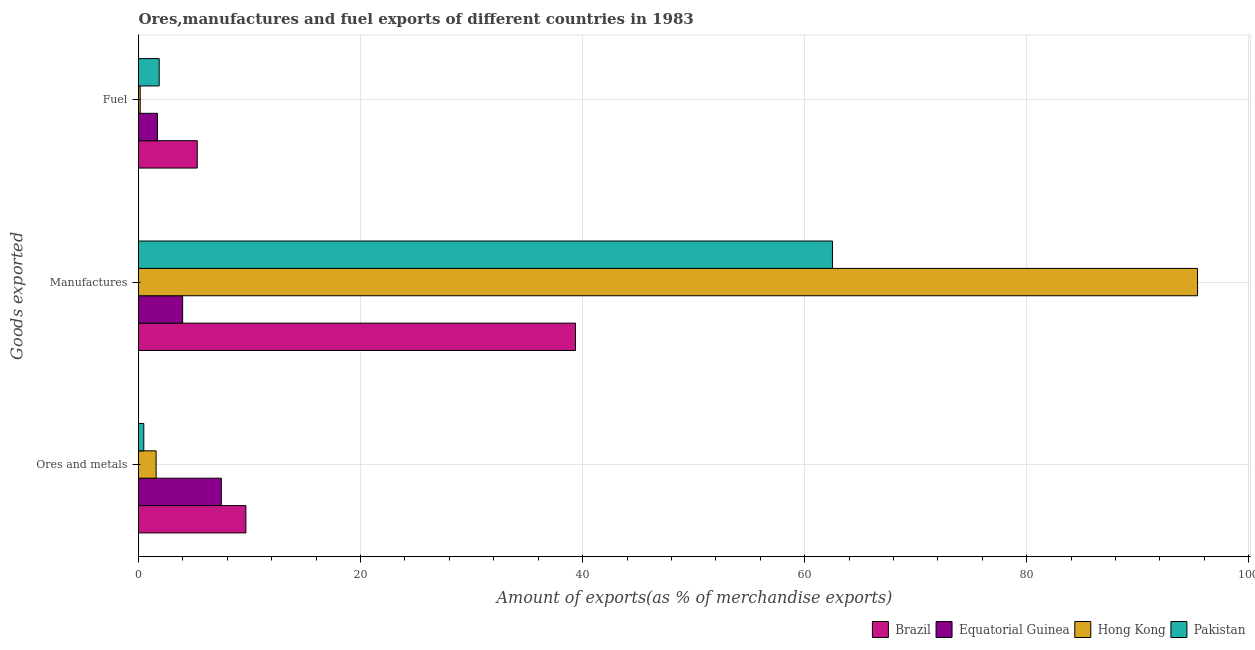Are the number of bars on each tick of the Y-axis equal?
Your answer should be compact. Yes. How many bars are there on the 3rd tick from the top?
Offer a very short reply. 4. What is the label of the 3rd group of bars from the top?
Make the answer very short. Ores and metals. What is the percentage of fuel exports in Hong Kong?
Offer a terse response. 0.15. Across all countries, what is the maximum percentage of ores and metals exports?
Keep it short and to the point. 9.67. Across all countries, what is the minimum percentage of ores and metals exports?
Keep it short and to the point. 0.48. In which country was the percentage of fuel exports maximum?
Offer a very short reply. Brazil. In which country was the percentage of manufactures exports minimum?
Your answer should be very brief. Equatorial Guinea. What is the total percentage of ores and metals exports in the graph?
Your answer should be very brief. 19.19. What is the difference between the percentage of manufactures exports in Brazil and that in Pakistan?
Offer a terse response. -23.15. What is the difference between the percentage of ores and metals exports in Pakistan and the percentage of fuel exports in Brazil?
Your answer should be very brief. -4.82. What is the average percentage of fuel exports per country?
Make the answer very short. 2.25. What is the difference between the percentage of fuel exports and percentage of ores and metals exports in Brazil?
Make the answer very short. -4.38. In how many countries, is the percentage of ores and metals exports greater than 36 %?
Provide a succinct answer. 0. What is the ratio of the percentage of ores and metals exports in Hong Kong to that in Pakistan?
Give a very brief answer. 3.33. Is the percentage of manufactures exports in Brazil less than that in Equatorial Guinea?
Offer a terse response. No. Is the difference between the percentage of ores and metals exports in Hong Kong and Pakistan greater than the difference between the percentage of fuel exports in Hong Kong and Pakistan?
Your response must be concise. Yes. What is the difference between the highest and the second highest percentage of manufactures exports?
Make the answer very short. 32.88. What is the difference between the highest and the lowest percentage of ores and metals exports?
Your answer should be very brief. 9.2. Is the sum of the percentage of ores and metals exports in Brazil and Equatorial Guinea greater than the maximum percentage of manufactures exports across all countries?
Provide a short and direct response. No. What does the 1st bar from the bottom in Ores and metals represents?
Offer a very short reply. Brazil. Are all the bars in the graph horizontal?
Give a very brief answer. Yes. What is the difference between two consecutive major ticks on the X-axis?
Your answer should be compact. 20. Are the values on the major ticks of X-axis written in scientific E-notation?
Keep it short and to the point. No. Does the graph contain any zero values?
Your answer should be very brief. No. Does the graph contain grids?
Offer a very short reply. Yes. Where does the legend appear in the graph?
Your answer should be compact. Bottom right. What is the title of the graph?
Provide a short and direct response. Ores,manufactures and fuel exports of different countries in 1983. What is the label or title of the X-axis?
Make the answer very short. Amount of exports(as % of merchandise exports). What is the label or title of the Y-axis?
Make the answer very short. Goods exported. What is the Amount of exports(as % of merchandise exports) of Brazil in Ores and metals?
Your answer should be very brief. 9.67. What is the Amount of exports(as % of merchandise exports) in Equatorial Guinea in Ores and metals?
Provide a short and direct response. 7.46. What is the Amount of exports(as % of merchandise exports) of Hong Kong in Ores and metals?
Give a very brief answer. 1.59. What is the Amount of exports(as % of merchandise exports) in Pakistan in Ores and metals?
Provide a succinct answer. 0.48. What is the Amount of exports(as % of merchandise exports) of Brazil in Manufactures?
Your response must be concise. 39.36. What is the Amount of exports(as % of merchandise exports) of Equatorial Guinea in Manufactures?
Your answer should be compact. 3.97. What is the Amount of exports(as % of merchandise exports) in Hong Kong in Manufactures?
Give a very brief answer. 95.39. What is the Amount of exports(as % of merchandise exports) in Pakistan in Manufactures?
Give a very brief answer. 62.51. What is the Amount of exports(as % of merchandise exports) in Brazil in Fuel?
Keep it short and to the point. 5.29. What is the Amount of exports(as % of merchandise exports) in Equatorial Guinea in Fuel?
Offer a very short reply. 1.71. What is the Amount of exports(as % of merchandise exports) in Hong Kong in Fuel?
Offer a terse response. 0.15. What is the Amount of exports(as % of merchandise exports) in Pakistan in Fuel?
Offer a terse response. 1.86. Across all Goods exported, what is the maximum Amount of exports(as % of merchandise exports) of Brazil?
Offer a terse response. 39.36. Across all Goods exported, what is the maximum Amount of exports(as % of merchandise exports) of Equatorial Guinea?
Your response must be concise. 7.46. Across all Goods exported, what is the maximum Amount of exports(as % of merchandise exports) of Hong Kong?
Offer a terse response. 95.39. Across all Goods exported, what is the maximum Amount of exports(as % of merchandise exports) of Pakistan?
Ensure brevity in your answer.  62.51. Across all Goods exported, what is the minimum Amount of exports(as % of merchandise exports) in Brazil?
Provide a short and direct response. 5.29. Across all Goods exported, what is the minimum Amount of exports(as % of merchandise exports) of Equatorial Guinea?
Give a very brief answer. 1.71. Across all Goods exported, what is the minimum Amount of exports(as % of merchandise exports) in Hong Kong?
Provide a succinct answer. 0.15. Across all Goods exported, what is the minimum Amount of exports(as % of merchandise exports) in Pakistan?
Your answer should be compact. 0.48. What is the total Amount of exports(as % of merchandise exports) of Brazil in the graph?
Offer a terse response. 54.32. What is the total Amount of exports(as % of merchandise exports) in Equatorial Guinea in the graph?
Your answer should be compact. 13.14. What is the total Amount of exports(as % of merchandise exports) of Hong Kong in the graph?
Offer a very short reply. 97.13. What is the total Amount of exports(as % of merchandise exports) in Pakistan in the graph?
Your response must be concise. 64.84. What is the difference between the Amount of exports(as % of merchandise exports) of Brazil in Ores and metals and that in Manufactures?
Give a very brief answer. -29.69. What is the difference between the Amount of exports(as % of merchandise exports) in Equatorial Guinea in Ores and metals and that in Manufactures?
Provide a short and direct response. 3.49. What is the difference between the Amount of exports(as % of merchandise exports) of Hong Kong in Ores and metals and that in Manufactures?
Keep it short and to the point. -93.8. What is the difference between the Amount of exports(as % of merchandise exports) in Pakistan in Ores and metals and that in Manufactures?
Make the answer very short. -62.03. What is the difference between the Amount of exports(as % of merchandise exports) in Brazil in Ores and metals and that in Fuel?
Your response must be concise. 4.38. What is the difference between the Amount of exports(as % of merchandise exports) of Equatorial Guinea in Ores and metals and that in Fuel?
Your response must be concise. 5.75. What is the difference between the Amount of exports(as % of merchandise exports) of Hong Kong in Ores and metals and that in Fuel?
Provide a succinct answer. 1.43. What is the difference between the Amount of exports(as % of merchandise exports) in Pakistan in Ores and metals and that in Fuel?
Ensure brevity in your answer.  -1.39. What is the difference between the Amount of exports(as % of merchandise exports) of Brazil in Manufactures and that in Fuel?
Provide a short and direct response. 34.07. What is the difference between the Amount of exports(as % of merchandise exports) of Equatorial Guinea in Manufactures and that in Fuel?
Give a very brief answer. 2.27. What is the difference between the Amount of exports(as % of merchandise exports) of Hong Kong in Manufactures and that in Fuel?
Keep it short and to the point. 95.24. What is the difference between the Amount of exports(as % of merchandise exports) in Pakistan in Manufactures and that in Fuel?
Make the answer very short. 60.64. What is the difference between the Amount of exports(as % of merchandise exports) in Brazil in Ores and metals and the Amount of exports(as % of merchandise exports) in Equatorial Guinea in Manufactures?
Your answer should be very brief. 5.7. What is the difference between the Amount of exports(as % of merchandise exports) of Brazil in Ores and metals and the Amount of exports(as % of merchandise exports) of Hong Kong in Manufactures?
Provide a short and direct response. -85.72. What is the difference between the Amount of exports(as % of merchandise exports) of Brazil in Ores and metals and the Amount of exports(as % of merchandise exports) of Pakistan in Manufactures?
Offer a very short reply. -52.83. What is the difference between the Amount of exports(as % of merchandise exports) in Equatorial Guinea in Ores and metals and the Amount of exports(as % of merchandise exports) in Hong Kong in Manufactures?
Offer a terse response. -87.93. What is the difference between the Amount of exports(as % of merchandise exports) in Equatorial Guinea in Ores and metals and the Amount of exports(as % of merchandise exports) in Pakistan in Manufactures?
Your response must be concise. -55.05. What is the difference between the Amount of exports(as % of merchandise exports) in Hong Kong in Ores and metals and the Amount of exports(as % of merchandise exports) in Pakistan in Manufactures?
Keep it short and to the point. -60.92. What is the difference between the Amount of exports(as % of merchandise exports) in Brazil in Ores and metals and the Amount of exports(as % of merchandise exports) in Equatorial Guinea in Fuel?
Provide a succinct answer. 7.96. What is the difference between the Amount of exports(as % of merchandise exports) of Brazil in Ores and metals and the Amount of exports(as % of merchandise exports) of Hong Kong in Fuel?
Ensure brevity in your answer.  9.52. What is the difference between the Amount of exports(as % of merchandise exports) of Brazil in Ores and metals and the Amount of exports(as % of merchandise exports) of Pakistan in Fuel?
Your answer should be compact. 7.81. What is the difference between the Amount of exports(as % of merchandise exports) in Equatorial Guinea in Ores and metals and the Amount of exports(as % of merchandise exports) in Hong Kong in Fuel?
Provide a short and direct response. 7.31. What is the difference between the Amount of exports(as % of merchandise exports) of Equatorial Guinea in Ores and metals and the Amount of exports(as % of merchandise exports) of Pakistan in Fuel?
Provide a short and direct response. 5.6. What is the difference between the Amount of exports(as % of merchandise exports) in Hong Kong in Ores and metals and the Amount of exports(as % of merchandise exports) in Pakistan in Fuel?
Offer a very short reply. -0.28. What is the difference between the Amount of exports(as % of merchandise exports) in Brazil in Manufactures and the Amount of exports(as % of merchandise exports) in Equatorial Guinea in Fuel?
Make the answer very short. 37.65. What is the difference between the Amount of exports(as % of merchandise exports) in Brazil in Manufactures and the Amount of exports(as % of merchandise exports) in Hong Kong in Fuel?
Provide a succinct answer. 39.21. What is the difference between the Amount of exports(as % of merchandise exports) in Brazil in Manufactures and the Amount of exports(as % of merchandise exports) in Pakistan in Fuel?
Keep it short and to the point. 37.5. What is the difference between the Amount of exports(as % of merchandise exports) in Equatorial Guinea in Manufactures and the Amount of exports(as % of merchandise exports) in Hong Kong in Fuel?
Your answer should be very brief. 3.82. What is the difference between the Amount of exports(as % of merchandise exports) of Equatorial Guinea in Manufactures and the Amount of exports(as % of merchandise exports) of Pakistan in Fuel?
Your response must be concise. 2.11. What is the difference between the Amount of exports(as % of merchandise exports) of Hong Kong in Manufactures and the Amount of exports(as % of merchandise exports) of Pakistan in Fuel?
Your answer should be compact. 93.53. What is the average Amount of exports(as % of merchandise exports) of Brazil per Goods exported?
Ensure brevity in your answer.  18.11. What is the average Amount of exports(as % of merchandise exports) of Equatorial Guinea per Goods exported?
Offer a terse response. 4.38. What is the average Amount of exports(as % of merchandise exports) in Hong Kong per Goods exported?
Give a very brief answer. 32.38. What is the average Amount of exports(as % of merchandise exports) of Pakistan per Goods exported?
Your answer should be very brief. 21.61. What is the difference between the Amount of exports(as % of merchandise exports) of Brazil and Amount of exports(as % of merchandise exports) of Equatorial Guinea in Ores and metals?
Offer a terse response. 2.21. What is the difference between the Amount of exports(as % of merchandise exports) of Brazil and Amount of exports(as % of merchandise exports) of Hong Kong in Ores and metals?
Offer a terse response. 8.09. What is the difference between the Amount of exports(as % of merchandise exports) of Brazil and Amount of exports(as % of merchandise exports) of Pakistan in Ores and metals?
Your answer should be compact. 9.2. What is the difference between the Amount of exports(as % of merchandise exports) in Equatorial Guinea and Amount of exports(as % of merchandise exports) in Hong Kong in Ores and metals?
Offer a terse response. 5.87. What is the difference between the Amount of exports(as % of merchandise exports) of Equatorial Guinea and Amount of exports(as % of merchandise exports) of Pakistan in Ores and metals?
Keep it short and to the point. 6.98. What is the difference between the Amount of exports(as % of merchandise exports) of Hong Kong and Amount of exports(as % of merchandise exports) of Pakistan in Ores and metals?
Offer a very short reply. 1.11. What is the difference between the Amount of exports(as % of merchandise exports) in Brazil and Amount of exports(as % of merchandise exports) in Equatorial Guinea in Manufactures?
Ensure brevity in your answer.  35.39. What is the difference between the Amount of exports(as % of merchandise exports) in Brazil and Amount of exports(as % of merchandise exports) in Hong Kong in Manufactures?
Keep it short and to the point. -56.03. What is the difference between the Amount of exports(as % of merchandise exports) of Brazil and Amount of exports(as % of merchandise exports) of Pakistan in Manufactures?
Your answer should be compact. -23.15. What is the difference between the Amount of exports(as % of merchandise exports) of Equatorial Guinea and Amount of exports(as % of merchandise exports) of Hong Kong in Manufactures?
Provide a succinct answer. -91.42. What is the difference between the Amount of exports(as % of merchandise exports) in Equatorial Guinea and Amount of exports(as % of merchandise exports) in Pakistan in Manufactures?
Give a very brief answer. -58.53. What is the difference between the Amount of exports(as % of merchandise exports) of Hong Kong and Amount of exports(as % of merchandise exports) of Pakistan in Manufactures?
Provide a short and direct response. 32.88. What is the difference between the Amount of exports(as % of merchandise exports) of Brazil and Amount of exports(as % of merchandise exports) of Equatorial Guinea in Fuel?
Give a very brief answer. 3.58. What is the difference between the Amount of exports(as % of merchandise exports) of Brazil and Amount of exports(as % of merchandise exports) of Hong Kong in Fuel?
Offer a very short reply. 5.14. What is the difference between the Amount of exports(as % of merchandise exports) in Brazil and Amount of exports(as % of merchandise exports) in Pakistan in Fuel?
Keep it short and to the point. 3.43. What is the difference between the Amount of exports(as % of merchandise exports) of Equatorial Guinea and Amount of exports(as % of merchandise exports) of Hong Kong in Fuel?
Offer a very short reply. 1.56. What is the difference between the Amount of exports(as % of merchandise exports) of Equatorial Guinea and Amount of exports(as % of merchandise exports) of Pakistan in Fuel?
Ensure brevity in your answer.  -0.15. What is the difference between the Amount of exports(as % of merchandise exports) of Hong Kong and Amount of exports(as % of merchandise exports) of Pakistan in Fuel?
Provide a short and direct response. -1.71. What is the ratio of the Amount of exports(as % of merchandise exports) of Brazil in Ores and metals to that in Manufactures?
Your response must be concise. 0.25. What is the ratio of the Amount of exports(as % of merchandise exports) of Equatorial Guinea in Ores and metals to that in Manufactures?
Keep it short and to the point. 1.88. What is the ratio of the Amount of exports(as % of merchandise exports) in Hong Kong in Ores and metals to that in Manufactures?
Your answer should be very brief. 0.02. What is the ratio of the Amount of exports(as % of merchandise exports) of Pakistan in Ores and metals to that in Manufactures?
Offer a terse response. 0.01. What is the ratio of the Amount of exports(as % of merchandise exports) of Brazil in Ores and metals to that in Fuel?
Make the answer very short. 1.83. What is the ratio of the Amount of exports(as % of merchandise exports) in Equatorial Guinea in Ores and metals to that in Fuel?
Your answer should be very brief. 4.37. What is the ratio of the Amount of exports(as % of merchandise exports) in Hong Kong in Ores and metals to that in Fuel?
Your response must be concise. 10.35. What is the ratio of the Amount of exports(as % of merchandise exports) in Pakistan in Ores and metals to that in Fuel?
Provide a succinct answer. 0.26. What is the ratio of the Amount of exports(as % of merchandise exports) of Brazil in Manufactures to that in Fuel?
Your answer should be very brief. 7.44. What is the ratio of the Amount of exports(as % of merchandise exports) of Equatorial Guinea in Manufactures to that in Fuel?
Ensure brevity in your answer.  2.33. What is the ratio of the Amount of exports(as % of merchandise exports) in Hong Kong in Manufactures to that in Fuel?
Ensure brevity in your answer.  622.48. What is the ratio of the Amount of exports(as % of merchandise exports) of Pakistan in Manufactures to that in Fuel?
Give a very brief answer. 33.57. What is the difference between the highest and the second highest Amount of exports(as % of merchandise exports) of Brazil?
Your answer should be compact. 29.69. What is the difference between the highest and the second highest Amount of exports(as % of merchandise exports) in Equatorial Guinea?
Keep it short and to the point. 3.49. What is the difference between the highest and the second highest Amount of exports(as % of merchandise exports) of Hong Kong?
Provide a succinct answer. 93.8. What is the difference between the highest and the second highest Amount of exports(as % of merchandise exports) in Pakistan?
Offer a very short reply. 60.64. What is the difference between the highest and the lowest Amount of exports(as % of merchandise exports) of Brazil?
Ensure brevity in your answer.  34.07. What is the difference between the highest and the lowest Amount of exports(as % of merchandise exports) in Equatorial Guinea?
Provide a succinct answer. 5.75. What is the difference between the highest and the lowest Amount of exports(as % of merchandise exports) in Hong Kong?
Your response must be concise. 95.24. What is the difference between the highest and the lowest Amount of exports(as % of merchandise exports) in Pakistan?
Ensure brevity in your answer.  62.03. 